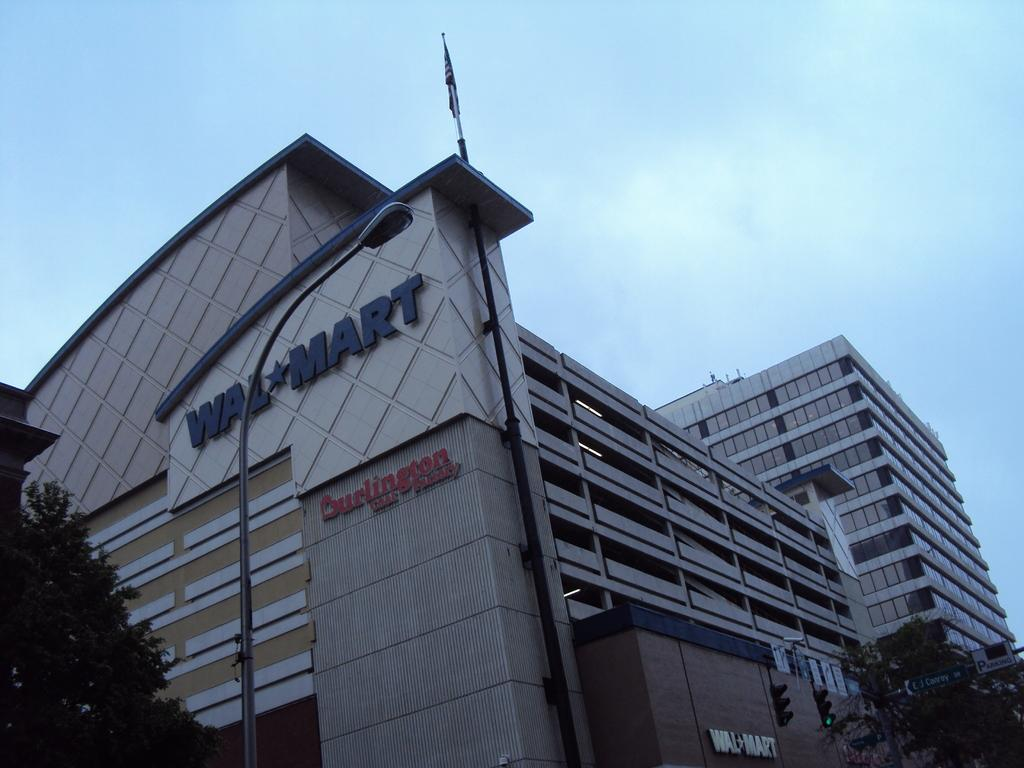What type of structure is visible in the image? There is a building in the image. What other natural elements can be seen in the image? There are trees in the image. How would you describe the sky in the image? The sky is blue and cloudy in the image. What type of lighting is present in the image? There is a pole light in the image. Are there any symbols or markers on the building? Yes, there is a flag on the building. What type of traffic control device is present in the image? There are traffic signal lights in the image. Where are the dinosaurs taking a bath in the image? There are no dinosaurs or baths present in the image. What type of cord is attached to the flag on the building? There is no cord visible in the image; only the flag on the building is present. 